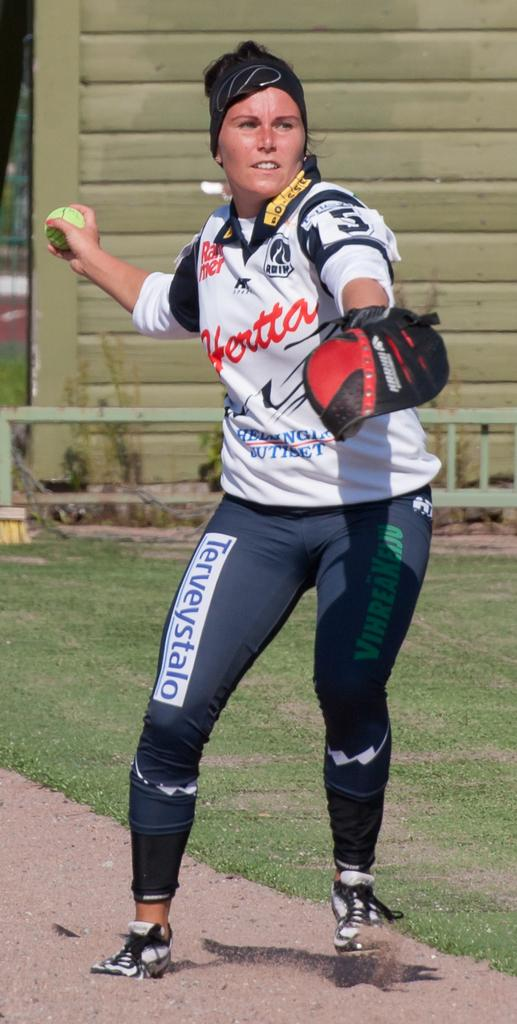Provide a one-sentence caption for the provided image. A woman in softball gear including a pair of Terveystalo leggings. 